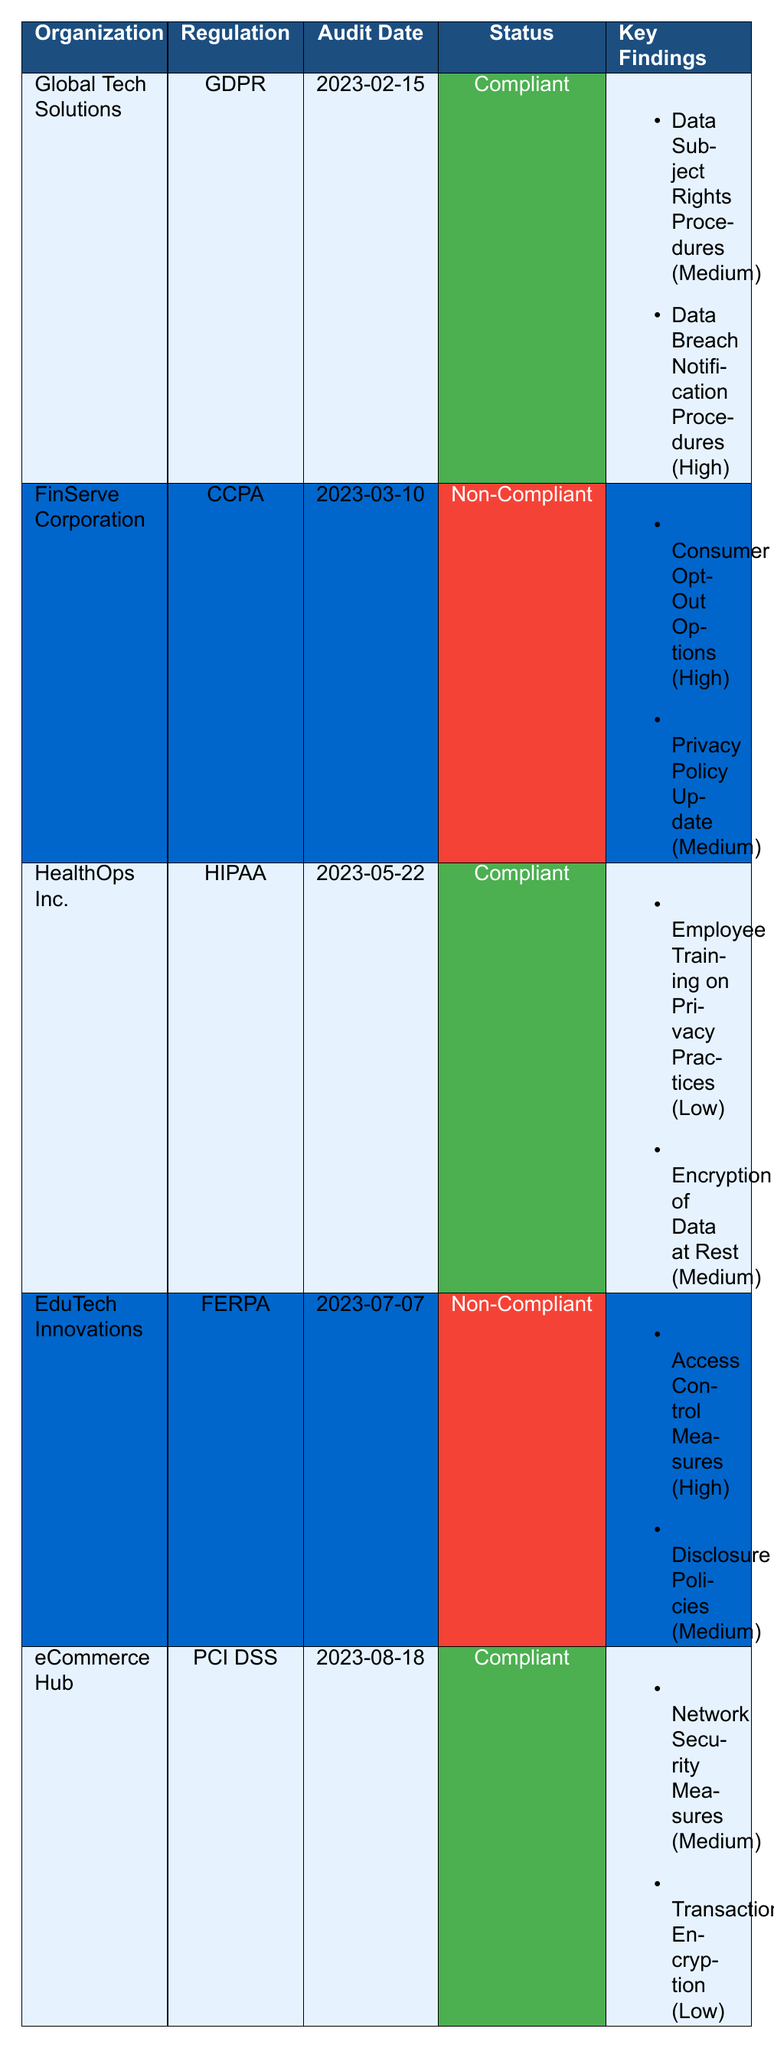What is the compliance status of Global Tech Solutions? The table shows that the compliance status for Global Tech Solutions is listed as "Compliant".
Answer: Compliant Which regulation has EduTech Innovations failed to comply with? The table indicates that EduTech Innovations is non-compliant with the FERPA regulation.
Answer: FERPA How many findings were reported for FinServe Corporation? The table lists two findings under FinServe Corporation: "Consumer Opt-Out Options" and "Privacy Policy Update", thus the total is 2.
Answer: 2 Is HealthOps Inc. compliant with HIPAA regulations? According to the table, HealthOps Inc. has a compliance status of "Compliant" with HIPAA.
Answer: Yes What is the average severity level of findings for compliant organizations? The compliant organizations are Global Tech Solutions, HealthOps Inc., and eCommerce Hub. The severity levels are Medium (2), Low (1), Medium (2) translating to low=1, medium=2, high=3 giving us a total of (2 + 1 + 2) = 5. With 3 compliant organizations, the average severity level is 5/3 which approximates to 1.67 (Low to Medium).
Answer: 1.67 What issue has the highest severity rating for EduTech Innovations? The table states that "Access Control Measures" is marked with a severity of "High", which is the highest for EduTech Innovations.
Answer: Access Control Measures Do all organizations audited comply with their respective regulations? The table indicates that FinServe Corporation and EduTech Innovations are non-compliant while Global Tech Solutions, HealthOps Inc., and eCommerce Hub are compliant. Therefore, not all organizations comply.
Answer: No How many organizations are compliant with the GDPR regulation? The table lists only one organization, Global Tech Solutions, that complies with GDPR, thus the total is 1.
Answer: 1 